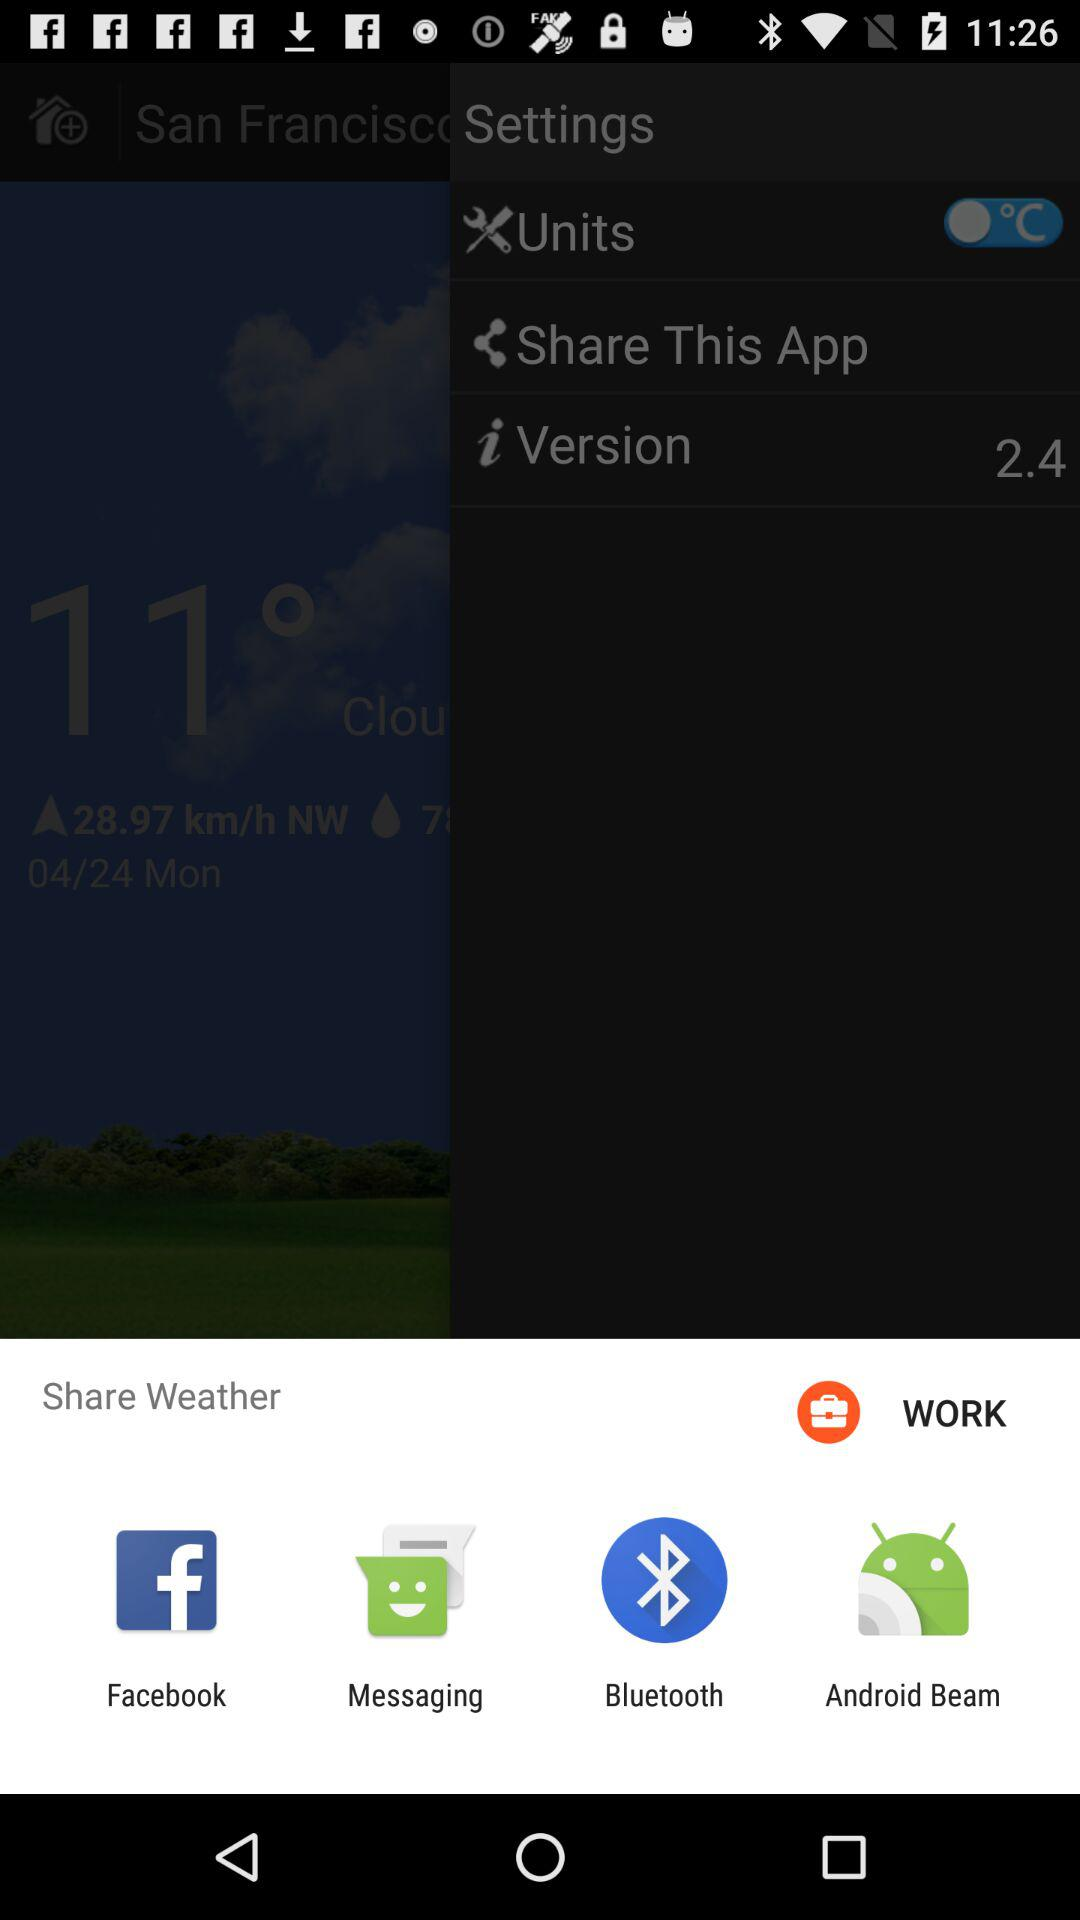What is the shown temperature unit? The shown temperature unit is °C. 